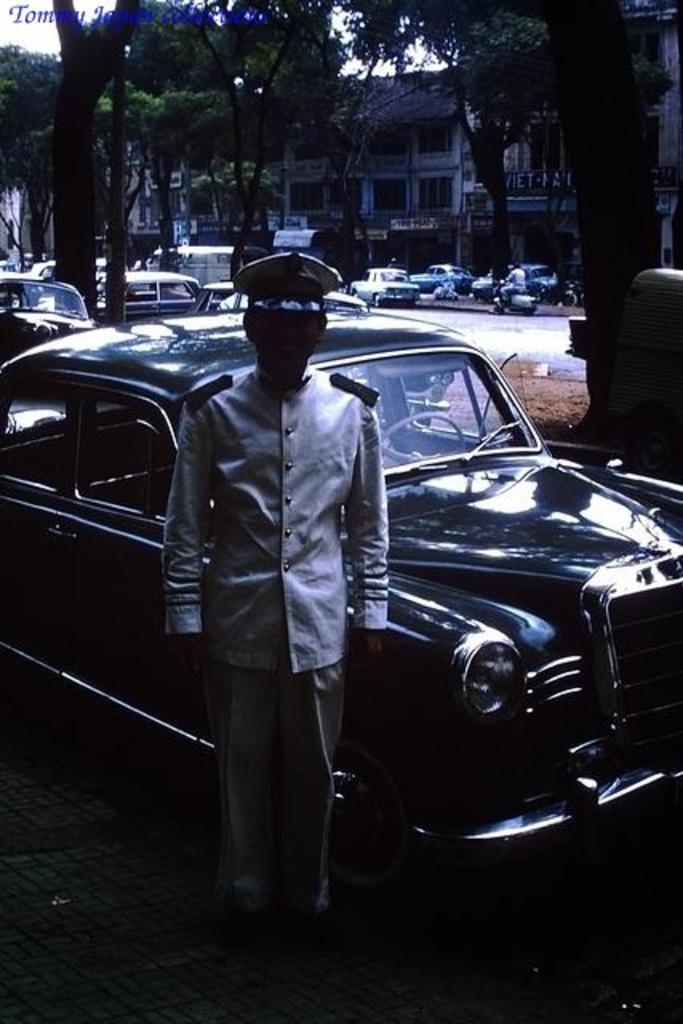Describe this image in one or two sentences. As we can see in the image there is a person standing in the front, cars, trees, motorcycle and buildings. 